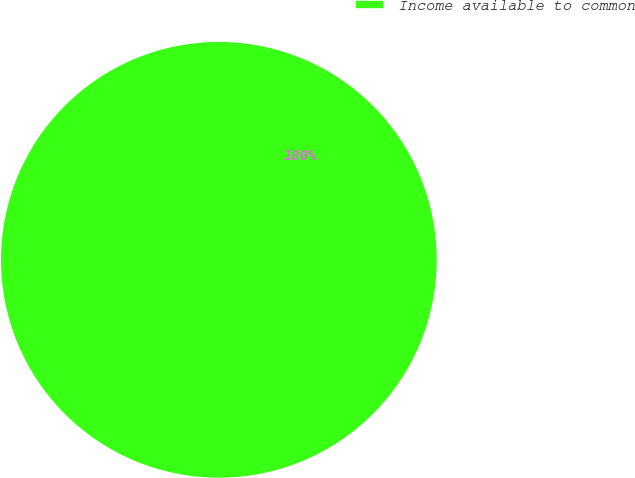Convert chart. <chart><loc_0><loc_0><loc_500><loc_500><pie_chart><fcel>Income available to common<nl><fcel>100.0%<nl></chart> 